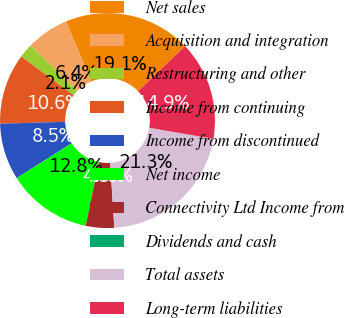Convert chart. <chart><loc_0><loc_0><loc_500><loc_500><pie_chart><fcel>Net sales<fcel>Acquisition and integration<fcel>Restructuring and other<fcel>Income from continuing<fcel>Income from discontinued<fcel>Net income<fcel>Connectivity Ltd Income from<fcel>Dividends and cash<fcel>Total assets<fcel>Long-term liabilities<nl><fcel>19.15%<fcel>6.38%<fcel>2.13%<fcel>10.64%<fcel>8.51%<fcel>12.77%<fcel>4.26%<fcel>0.0%<fcel>21.27%<fcel>14.89%<nl></chart> 